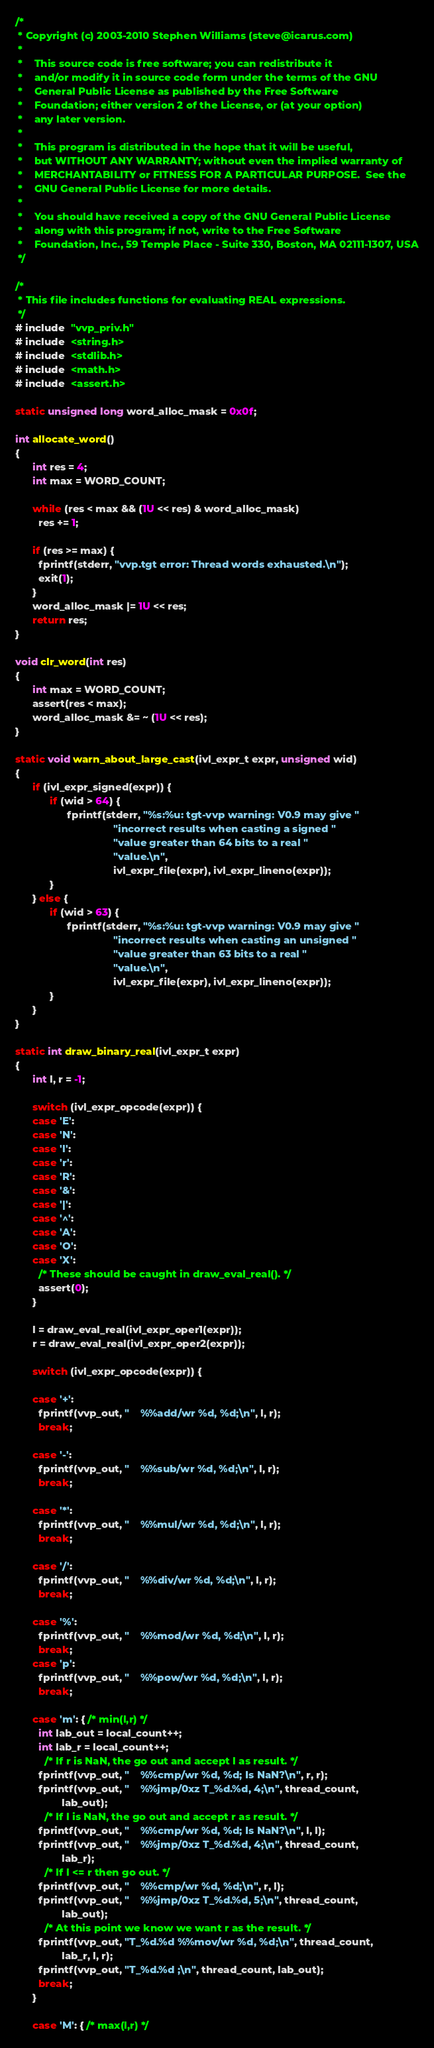Convert code to text. <code><loc_0><loc_0><loc_500><loc_500><_C_>/*
 * Copyright (c) 2003-2010 Stephen Williams (steve@icarus.com)
 *
 *    This source code is free software; you can redistribute it
 *    and/or modify it in source code form under the terms of the GNU
 *    General Public License as published by the Free Software
 *    Foundation; either version 2 of the License, or (at your option)
 *    any later version.
 *
 *    This program is distributed in the hope that it will be useful,
 *    but WITHOUT ANY WARRANTY; without even the implied warranty of
 *    MERCHANTABILITY or FITNESS FOR A PARTICULAR PURPOSE.  See the
 *    GNU General Public License for more details.
 *
 *    You should have received a copy of the GNU General Public License
 *    along with this program; if not, write to the Free Software
 *    Foundation, Inc., 59 Temple Place - Suite 330, Boston, MA 02111-1307, USA
 */

/*
 * This file includes functions for evaluating REAL expressions.
 */
# include  "vvp_priv.h"
# include  <string.h>
# include  <stdlib.h>
# include  <math.h>
# include  <assert.h>

static unsigned long word_alloc_mask = 0x0f;

int allocate_word()
{
      int res = 4;
      int max = WORD_COUNT;

      while (res < max && (1U << res) & word_alloc_mask)
	    res += 1;

      if (res >= max) {
	    fprintf(stderr, "vvp.tgt error: Thread words exhausted.\n");
	    exit(1);
      }
      word_alloc_mask |= 1U << res;
      return res;
}

void clr_word(int res)
{
      int max = WORD_COUNT;
      assert(res < max);
      word_alloc_mask &= ~ (1U << res);
}

static void warn_about_large_cast(ivl_expr_t expr, unsigned wid)
{
      if (ivl_expr_signed(expr)) {
            if (wid > 64) {
                  fprintf(stderr, "%s:%u: tgt-vvp warning: V0.9 may give "
                                  "incorrect results when casting a signed "
                                  "value greater than 64 bits to a real "
                                  "value.\n",
                                  ivl_expr_file(expr), ivl_expr_lineno(expr));
            }
      } else {
            if (wid > 63) {
                  fprintf(stderr, "%s:%u: tgt-vvp warning: V0.9 may give "
                                  "incorrect results when casting an unsigned "
                                  "value greater than 63 bits to a real "
                                  "value.\n",
                                  ivl_expr_file(expr), ivl_expr_lineno(expr));
            }
      }
}

static int draw_binary_real(ivl_expr_t expr)
{
      int l, r = -1;

      switch (ivl_expr_opcode(expr)) {
	  case 'E':
	  case 'N':
	  case 'l':
	  case 'r':
	  case 'R':
	  case '&':
	  case '|':
	  case '^':
	  case 'A':
	  case 'O':
	  case 'X':
	    /* These should be caught in draw_eval_real(). */
	    assert(0);
      }

      l = draw_eval_real(ivl_expr_oper1(expr));
      r = draw_eval_real(ivl_expr_oper2(expr));

      switch (ivl_expr_opcode(expr)) {

	  case '+':
	    fprintf(vvp_out, "    %%add/wr %d, %d;\n", l, r);
	    break;

	  case '-':
	    fprintf(vvp_out, "    %%sub/wr %d, %d;\n", l, r);
	    break;

	  case '*':
	    fprintf(vvp_out, "    %%mul/wr %d, %d;\n", l, r);
	    break;

	  case '/':
	    fprintf(vvp_out, "    %%div/wr %d, %d;\n", l, r);
	    break;

	  case '%':
	    fprintf(vvp_out, "    %%mod/wr %d, %d;\n", l, r);
	    break;
	  case 'p':
	    fprintf(vvp_out, "    %%pow/wr %d, %d;\n", l, r);
	    break;

	  case 'm': { /* min(l,r) */
		int lab_out = local_count++;
		int lab_r = local_count++;
		  /* If r is NaN, the go out and accept l as result. */
		fprintf(vvp_out, "    %%cmp/wr %d, %d; Is NaN?\n", r, r);
		fprintf(vvp_out, "    %%jmp/0xz T_%d.%d, 4;\n", thread_count,
		        lab_out);
		  /* If l is NaN, the go out and accept r as result. */
		fprintf(vvp_out, "    %%cmp/wr %d, %d; Is NaN?\n", l, l);
		fprintf(vvp_out, "    %%jmp/0xz T_%d.%d, 4;\n", thread_count,
		        lab_r);
		  /* If l <= r then go out. */
		fprintf(vvp_out, "    %%cmp/wr %d, %d;\n", r, l);
		fprintf(vvp_out, "    %%jmp/0xz T_%d.%d, 5;\n", thread_count,
		        lab_out);
		  /* At this point we know we want r as the result. */
		fprintf(vvp_out, "T_%d.%d %%mov/wr %d, %d;\n", thread_count,
		        lab_r, l, r);
		fprintf(vvp_out, "T_%d.%d ;\n", thread_count, lab_out);
		break;
	  }

	  case 'M': { /* max(l,r) */</code> 